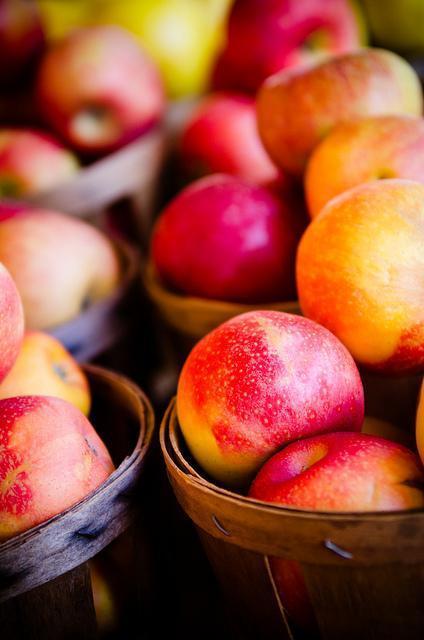How many apples are there?
Give a very brief answer. 11. How many bowls are there?
Give a very brief answer. 3. How many cars are in the intersection?
Give a very brief answer. 0. 